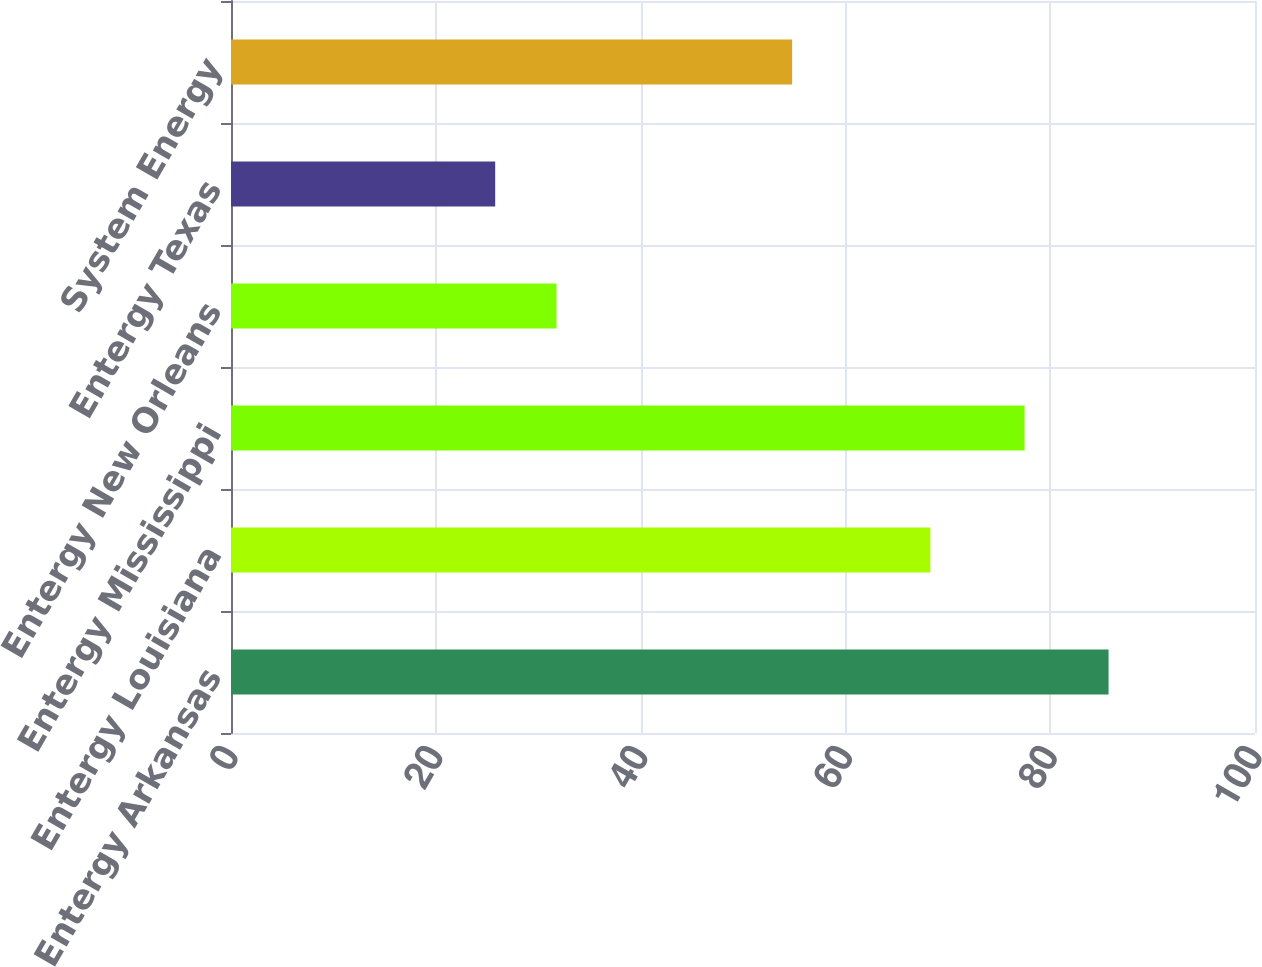<chart> <loc_0><loc_0><loc_500><loc_500><bar_chart><fcel>Entergy Arkansas<fcel>Entergy Louisiana<fcel>Entergy Mississippi<fcel>Entergy New Orleans<fcel>Entergy Texas<fcel>System Energy<nl><fcel>85.7<fcel>68.3<fcel>77.5<fcel>31.79<fcel>25.8<fcel>54.8<nl></chart> 